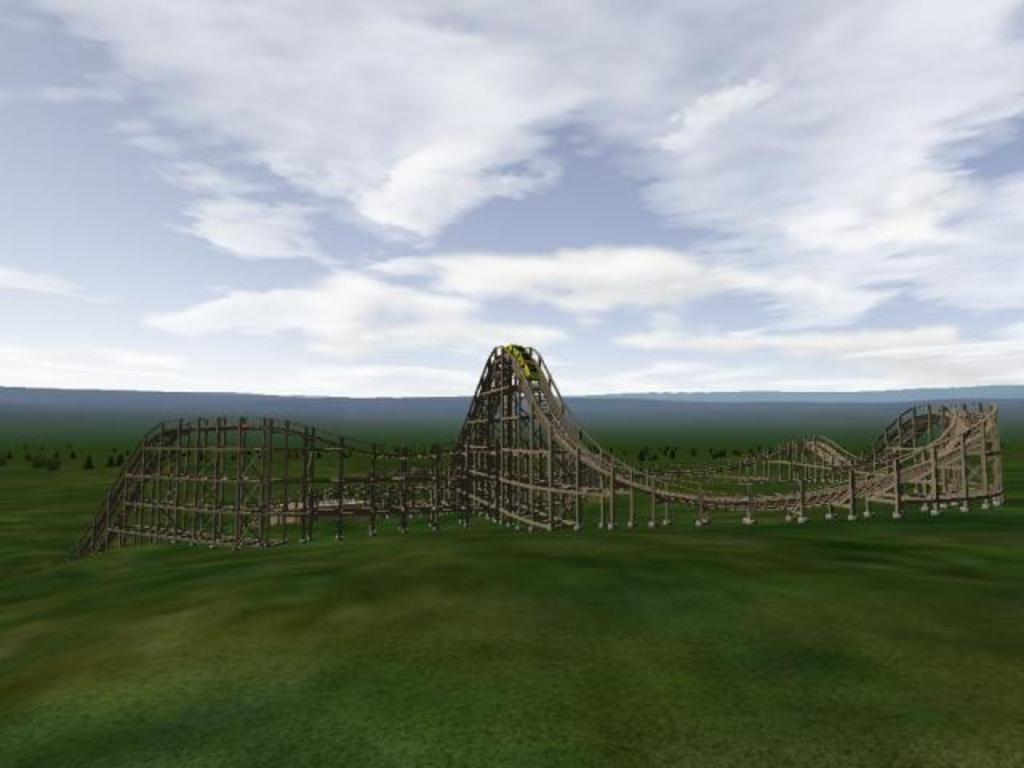Please provide a concise description of this image. In this image we can see an animated picture of a roller coaster ramp. In the background, we can see the cloudy sky. 